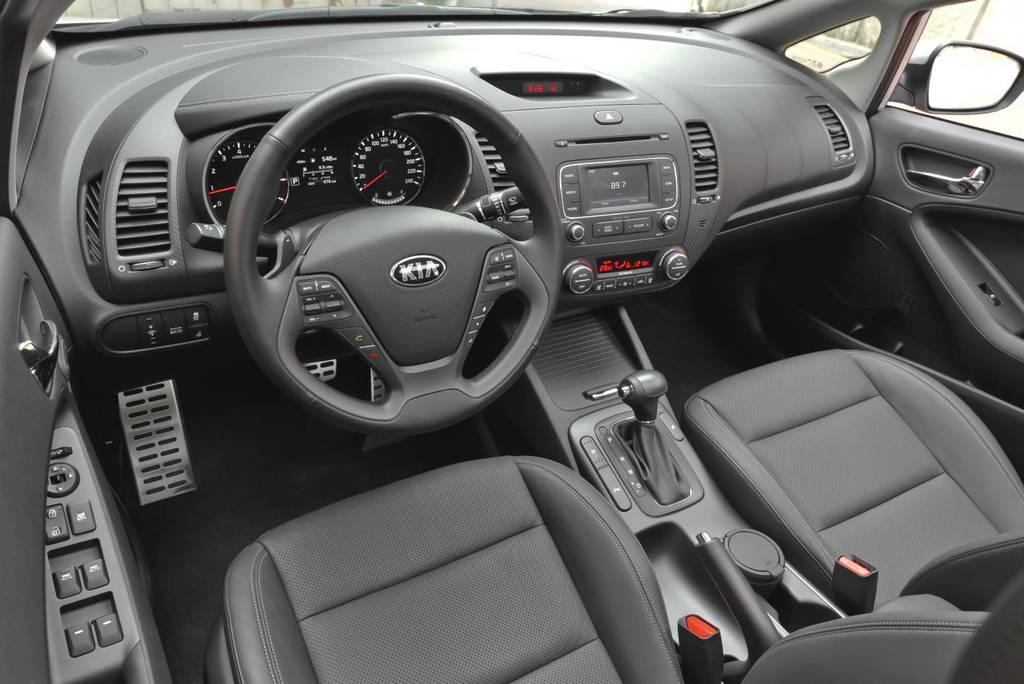What type of vehicle is shown in the image? The image is an inside view of a car. What is the main control device in the car? There is a steering wheel in the image. What displays information and controls in the car? There is a dashboard in the image. What are the seats for passengers in the car? There are car seats in the image. How can the driver see the side of the car? There is a side mirror visible in the image. What type of cub can be seen playing with a bottle of poison in the image? There is no cub or bottle of poison present in the image; it is an inside view of a car. 